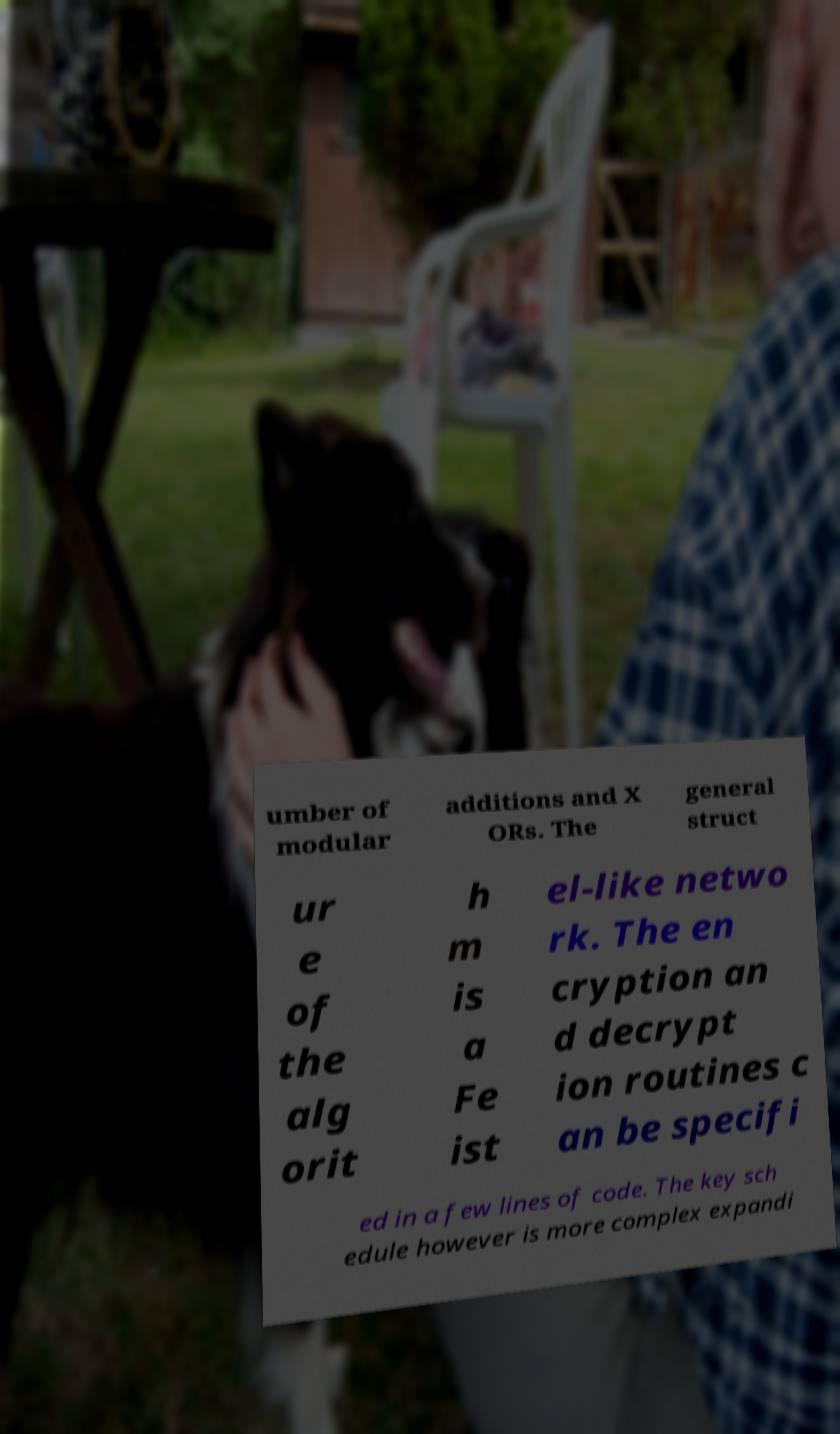Please identify and transcribe the text found in this image. umber of modular additions and X ORs. The general struct ur e of the alg orit h m is a Fe ist el-like netwo rk. The en cryption an d decrypt ion routines c an be specifi ed in a few lines of code. The key sch edule however is more complex expandi 